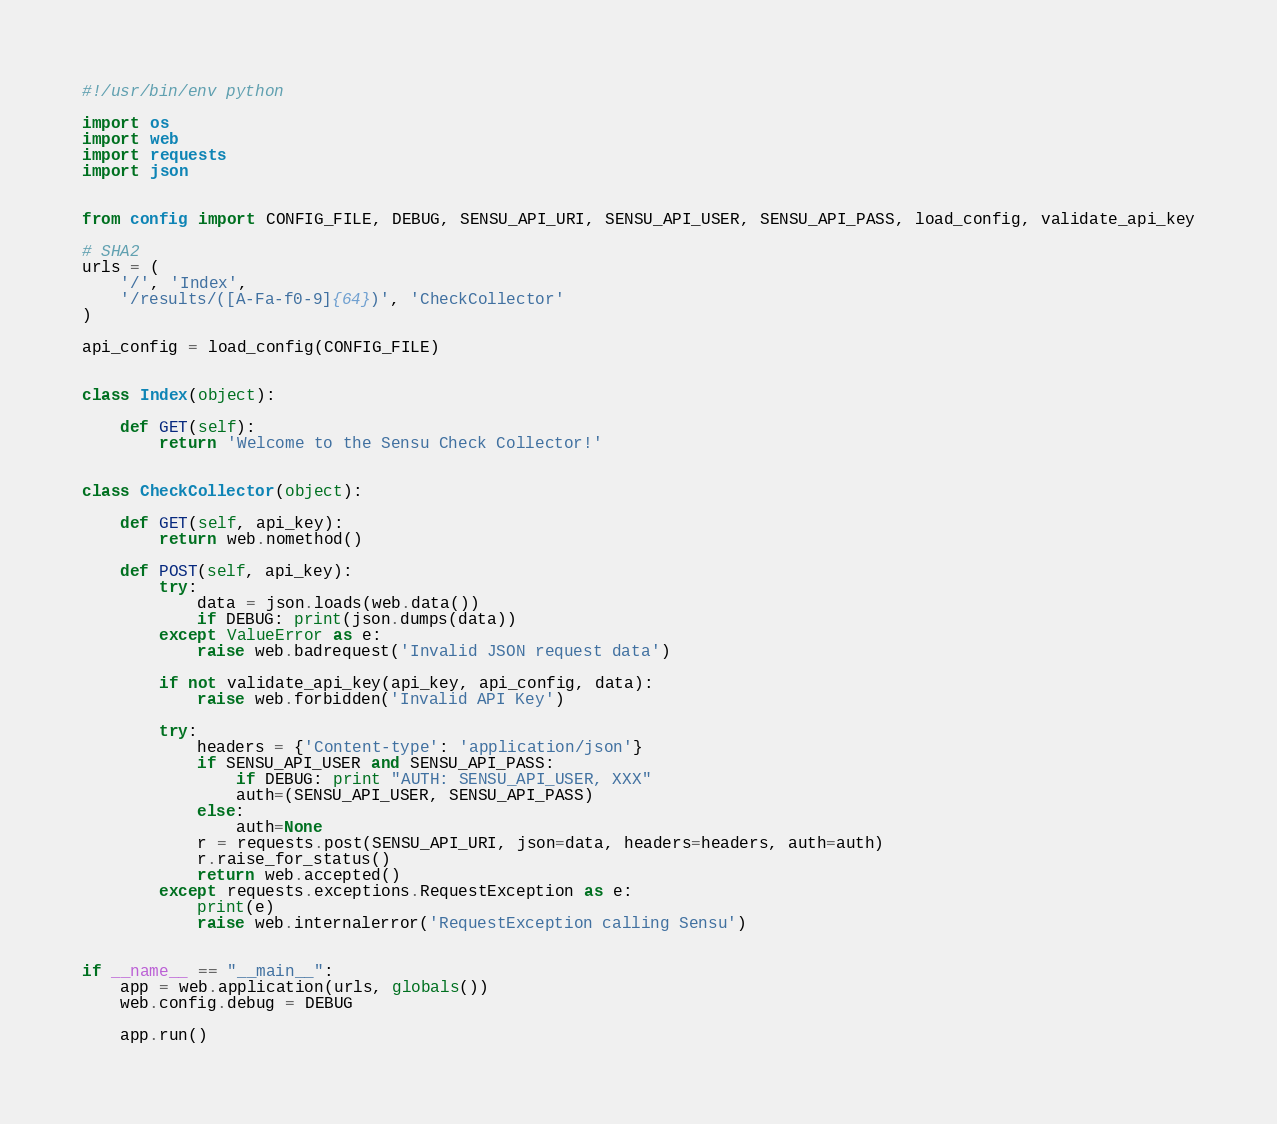Convert code to text. <code><loc_0><loc_0><loc_500><loc_500><_Python_>#!/usr/bin/env python

import os
import web
import requests
import json


from config import CONFIG_FILE, DEBUG, SENSU_API_URI, SENSU_API_USER, SENSU_API_PASS, load_config, validate_api_key

# SHA2
urls = (
    '/', 'Index',
    '/results/([A-Fa-f0-9]{64})', 'CheckCollector'
)

api_config = load_config(CONFIG_FILE)


class Index(object):

    def GET(self):
        return 'Welcome to the Sensu Check Collector!'


class CheckCollector(object):

    def GET(self, api_key):
        return web.nomethod()

    def POST(self, api_key):
        try:
            data = json.loads(web.data())
            if DEBUG: print(json.dumps(data))
        except ValueError as e:
            raise web.badrequest('Invalid JSON request data')

        if not validate_api_key(api_key, api_config, data):
            raise web.forbidden('Invalid API Key')

        try:
            headers = {'Content-type': 'application/json'}
            if SENSU_API_USER and SENSU_API_PASS:
                if DEBUG: print "AUTH: SENSU_API_USER, XXX"
                auth=(SENSU_API_USER, SENSU_API_PASS)
            else:
                auth=None
            r = requests.post(SENSU_API_URI, json=data, headers=headers, auth=auth)
            r.raise_for_status()
            return web.accepted()
        except requests.exceptions.RequestException as e:
            print(e)
            raise web.internalerror('RequestException calling Sensu')


if __name__ == "__main__":
    app = web.application(urls, globals())
    web.config.debug = DEBUG

    app.run()
</code> 